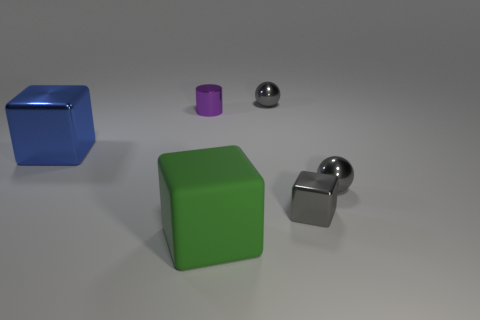Add 1 tiny gray spheres. How many objects exist? 7 Subtract all spheres. How many objects are left? 4 Add 2 green metal cubes. How many green metal cubes exist? 2 Subtract 0 yellow spheres. How many objects are left? 6 Subtract all tiny gray shiny spheres. Subtract all green cubes. How many objects are left? 3 Add 6 tiny purple things. How many tiny purple things are left? 7 